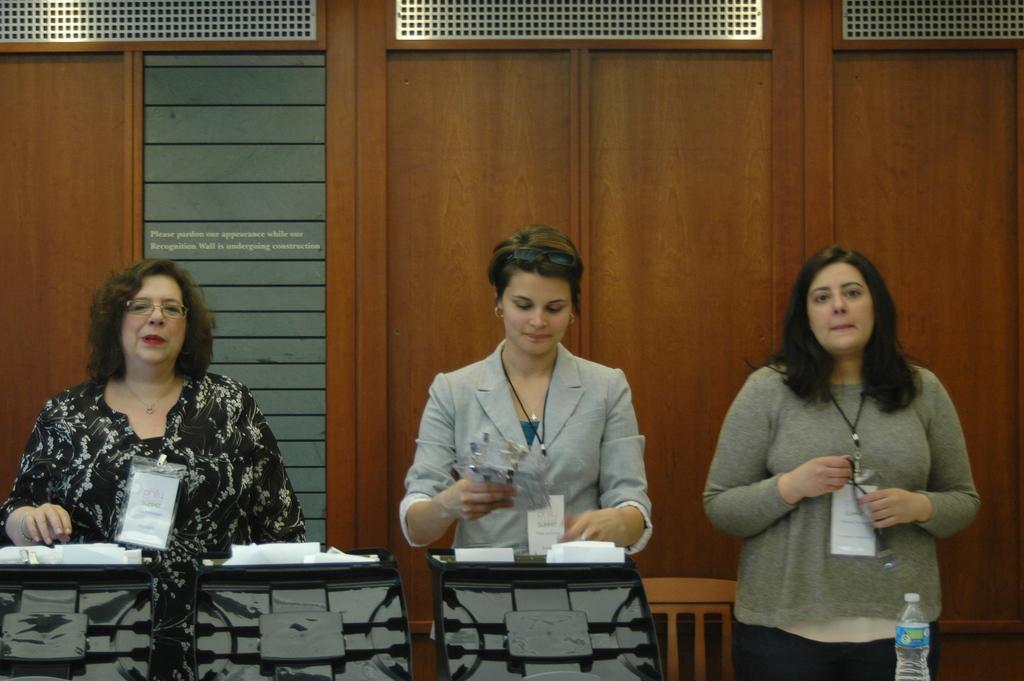How would you summarize this image in a sentence or two? There are three women in this picture. Two of them were standing near the podiums on which some papers were there. One of the woman is standing in the right side. In the background there is a door. 